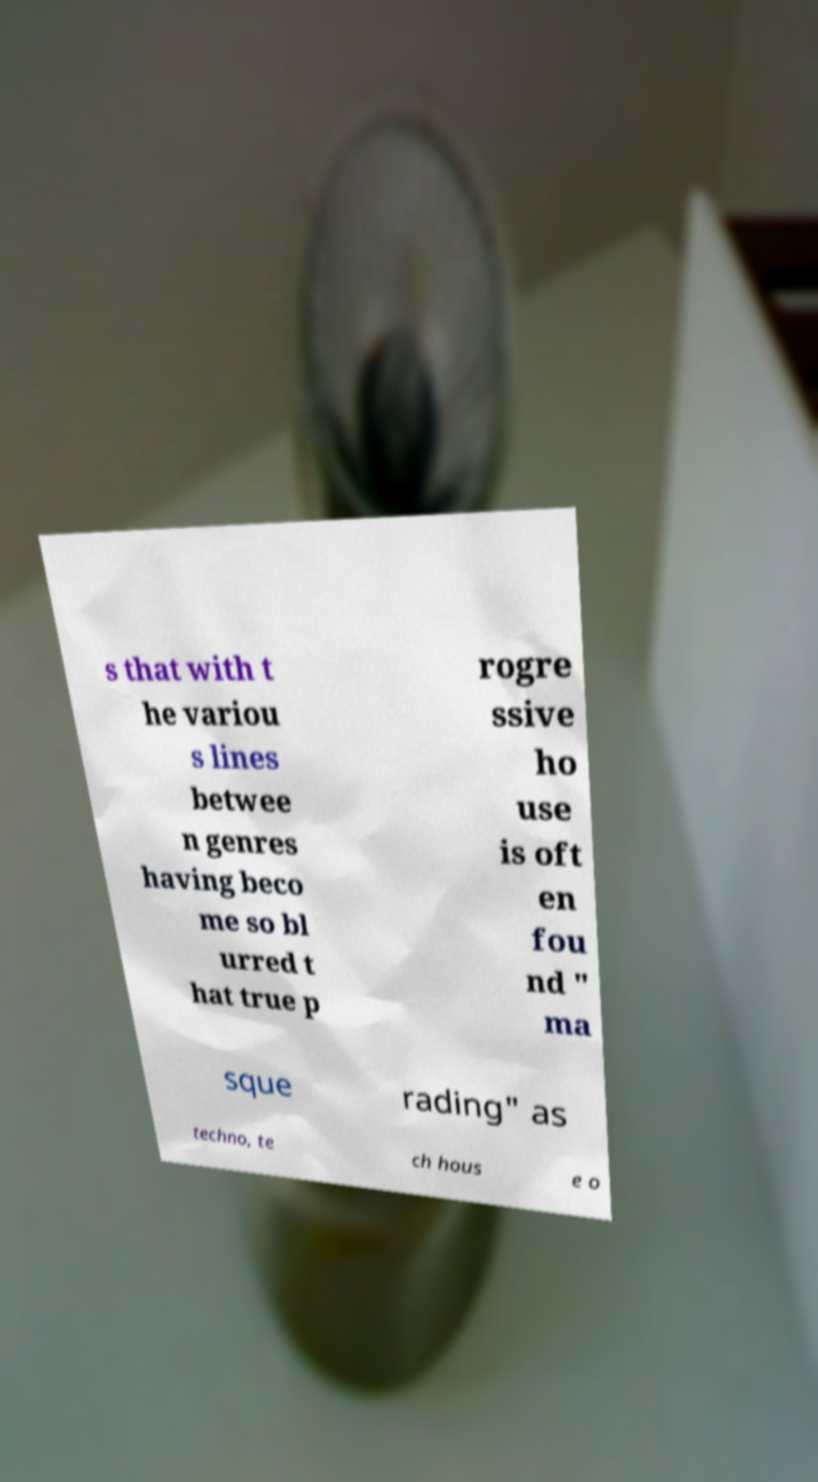Please identify and transcribe the text found in this image. s that with t he variou s lines betwee n genres having beco me so bl urred t hat true p rogre ssive ho use is oft en fou nd " ma sque rading" as techno, te ch hous e o 